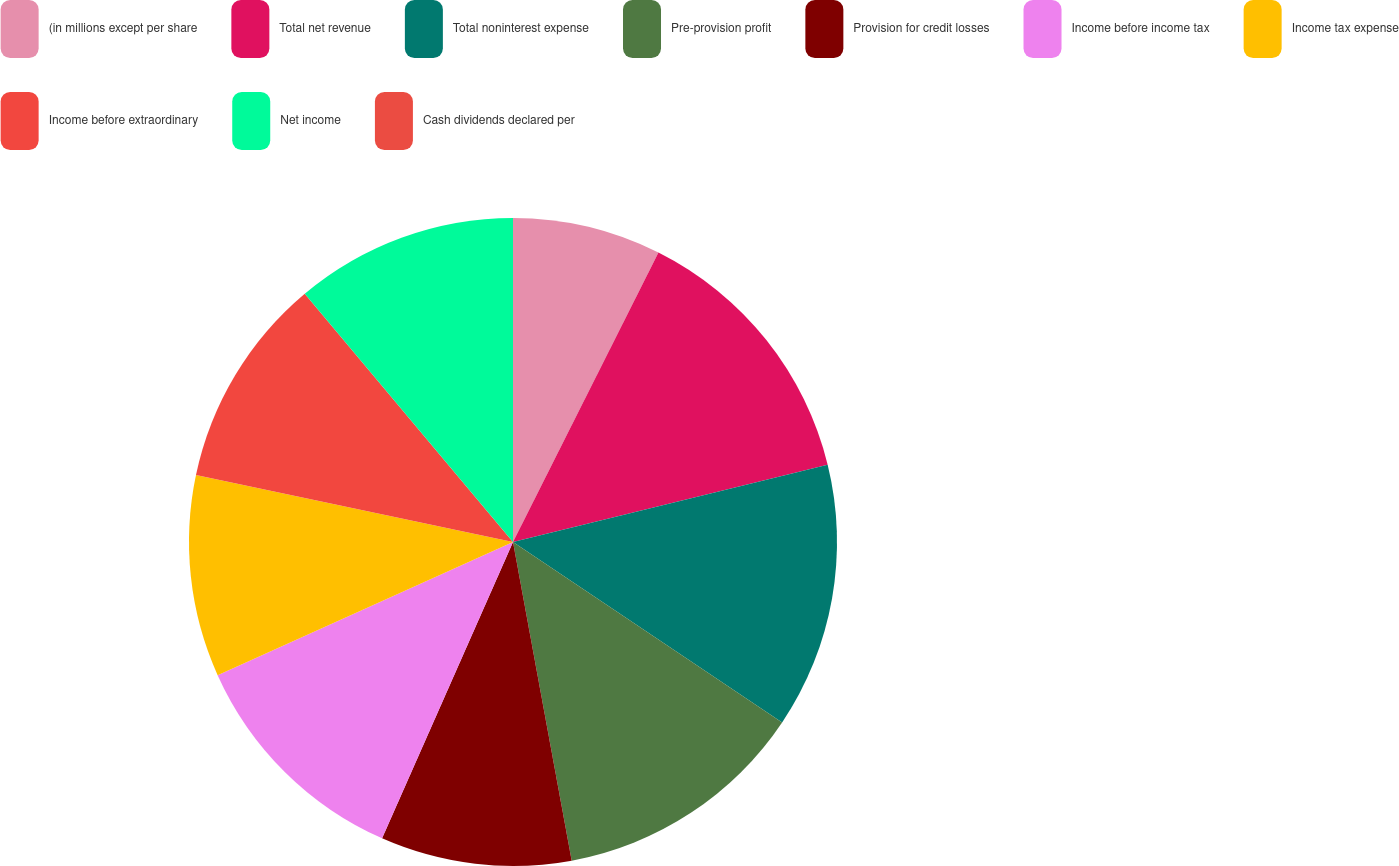Convert chart. <chart><loc_0><loc_0><loc_500><loc_500><pie_chart><fcel>(in millions except per share<fcel>Total net revenue<fcel>Total noninterest expense<fcel>Pre-provision profit<fcel>Provision for credit losses<fcel>Income before income tax<fcel>Income tax expense<fcel>Income before extraordinary<fcel>Net income<fcel>Cash dividends declared per<nl><fcel>7.41%<fcel>13.76%<fcel>13.23%<fcel>12.7%<fcel>9.52%<fcel>11.64%<fcel>10.05%<fcel>10.58%<fcel>11.11%<fcel>0.0%<nl></chart> 